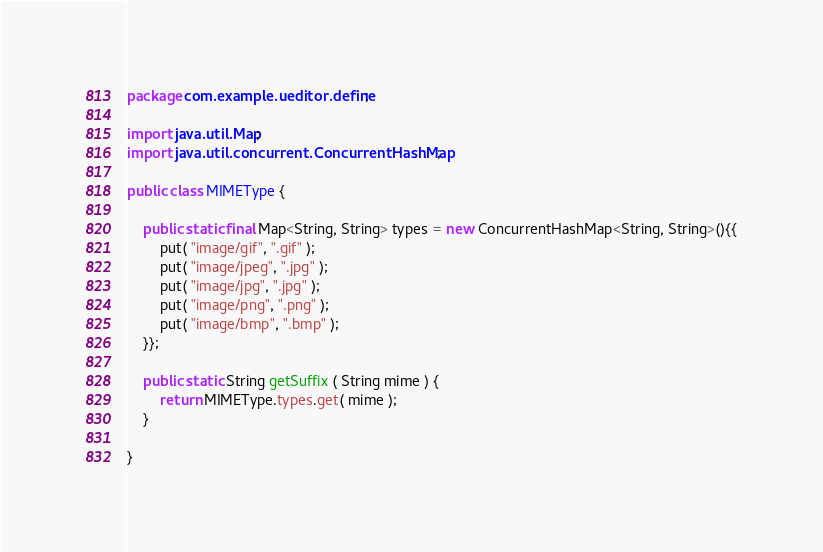Convert code to text. <code><loc_0><loc_0><loc_500><loc_500><_Java_>package com.example.ueditor.define;

import java.util.Map;
import java.util.concurrent.ConcurrentHashMap;

public class MIMEType {

    public static final Map<String, String> types = new ConcurrentHashMap<String, String>(){{
        put( "image/gif", ".gif" );
        put( "image/jpeg", ".jpg" );
        put( "image/jpg", ".jpg" );
        put( "image/png", ".png" );
        put( "image/bmp", ".bmp" );
    }};

    public static String getSuffix ( String mime ) {
        return MIMEType.types.get( mime );
    }

}
</code> 